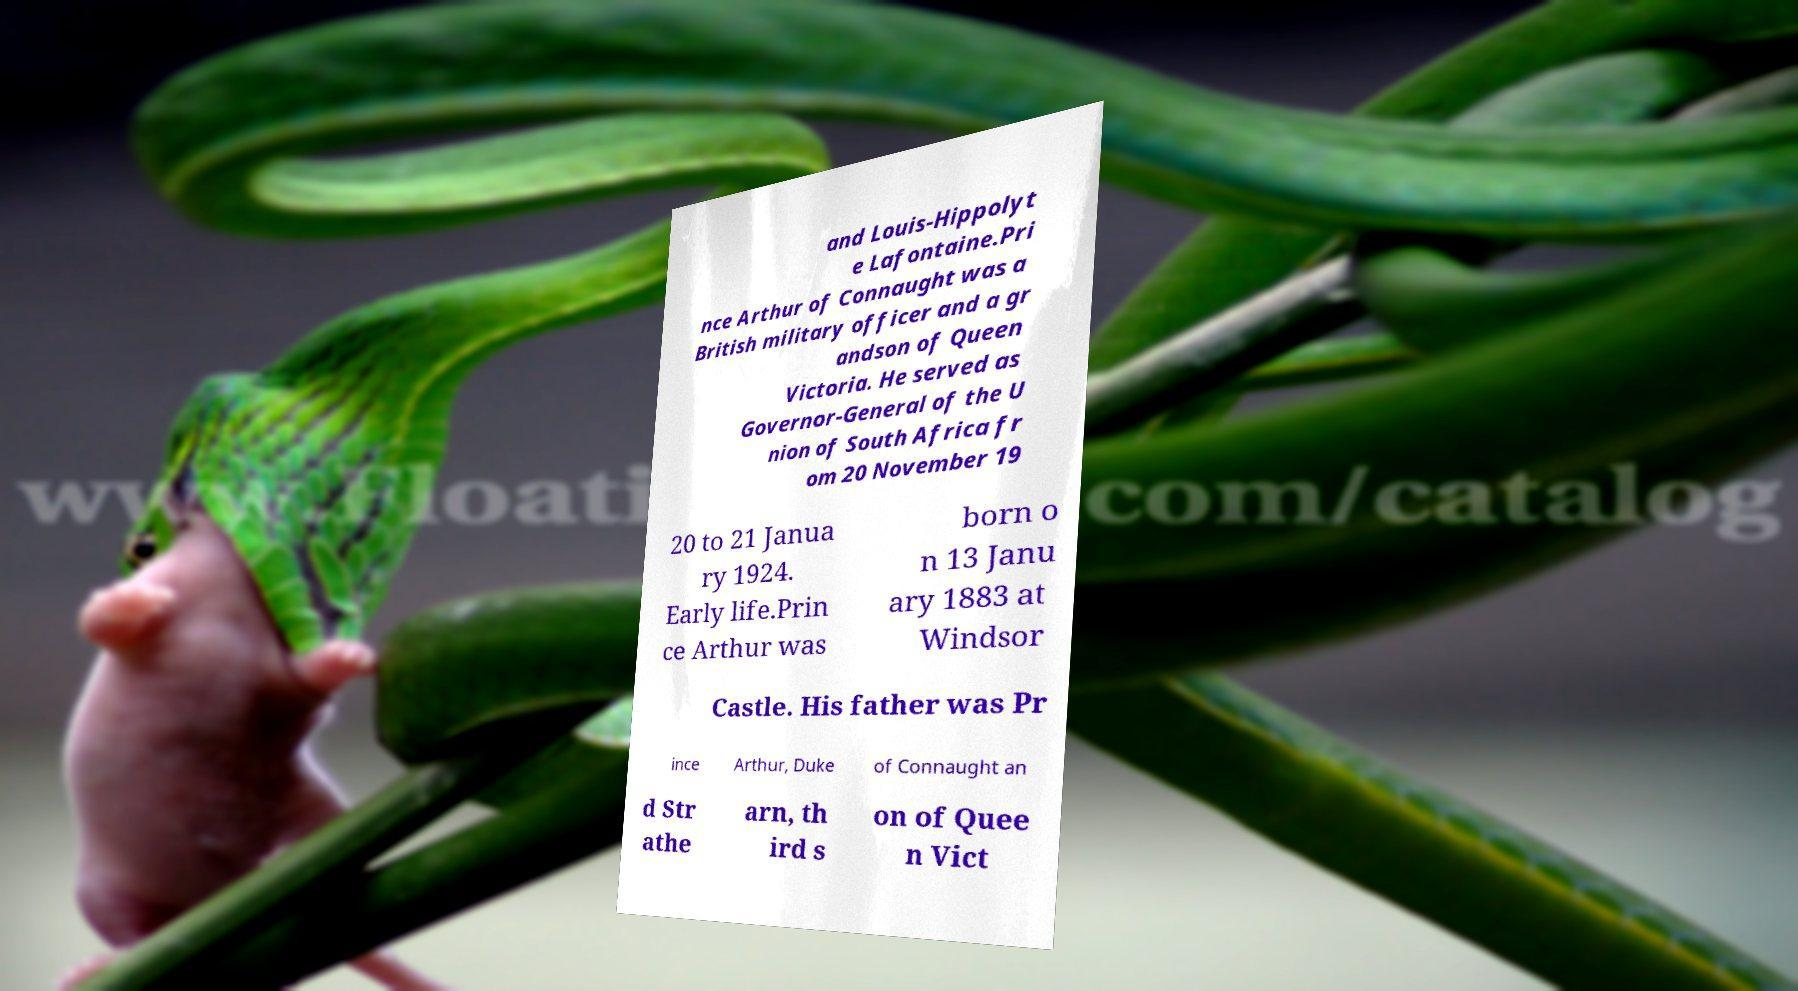There's text embedded in this image that I need extracted. Can you transcribe it verbatim? and Louis-Hippolyt e Lafontaine.Pri nce Arthur of Connaught was a British military officer and a gr andson of Queen Victoria. He served as Governor-General of the U nion of South Africa fr om 20 November 19 20 to 21 Janua ry 1924. Early life.Prin ce Arthur was born o n 13 Janu ary 1883 at Windsor Castle. His father was Pr ince Arthur, Duke of Connaught an d Str athe arn, th ird s on of Quee n Vict 